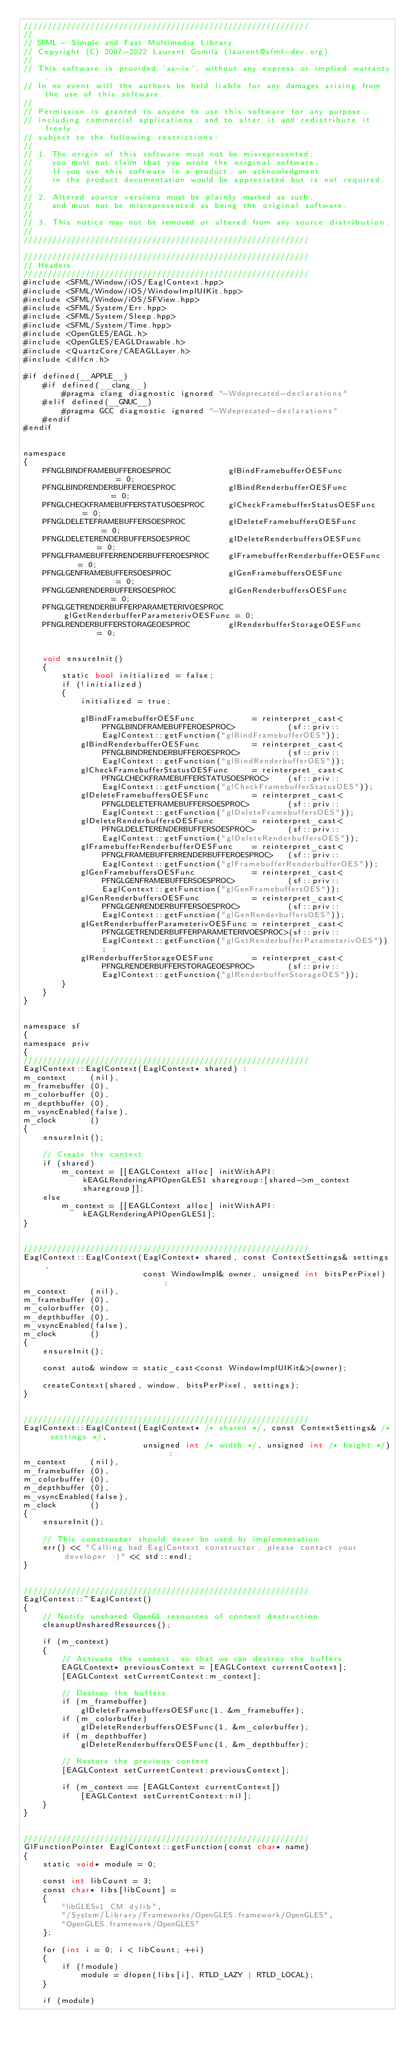<code> <loc_0><loc_0><loc_500><loc_500><_ObjectiveC_>////////////////////////////////////////////////////////////
//
// SFML - Simple and Fast Multimedia Library
// Copyright (C) 2007-2022 Laurent Gomila (laurent@sfml-dev.org)
//
// This software is provided 'as-is', without any express or implied warranty.
// In no event will the authors be held liable for any damages arising from the use of this software.
//
// Permission is granted to anyone to use this software for any purpose,
// including commercial applications, and to alter it and redistribute it freely,
// subject to the following restrictions:
//
// 1. The origin of this software must not be misrepresented;
//    you must not claim that you wrote the original software.
//    If you use this software in a product, an acknowledgment
//    in the product documentation would be appreciated but is not required.
//
// 2. Altered source versions must be plainly marked as such,
//    and must not be misrepresented as being the original software.
//
// 3. This notice may not be removed or altered from any source distribution.
//
////////////////////////////////////////////////////////////

////////////////////////////////////////////////////////////
// Headers
////////////////////////////////////////////////////////////
#include <SFML/Window/iOS/EaglContext.hpp>
#include <SFML/Window/iOS/WindowImplUIKit.hpp>
#include <SFML/Window/iOS/SFView.hpp>
#include <SFML/System/Err.hpp>
#include <SFML/System/Sleep.hpp>
#include <SFML/System/Time.hpp>
#include <OpenGLES/EAGL.h>
#include <OpenGLES/EAGLDrawable.h>
#include <QuartzCore/CAEAGLLayer.h>
#include <dlfcn.h>

#if defined(__APPLE__)
    #if defined(__clang__)
        #pragma clang diagnostic ignored "-Wdeprecated-declarations"
    #elif defined(__GNUC__)
        #pragma GCC diagnostic ignored "-Wdeprecated-declarations"
    #endif
#endif


namespace
{
    PFNGLBINDFRAMEBUFFEROESPROC            glBindFramebufferOESFunc            = 0;
    PFNGLBINDRENDERBUFFEROESPROC           glBindRenderbufferOESFunc           = 0;
    PFNGLCHECKFRAMEBUFFERSTATUSOESPROC     glCheckFramebufferStatusOESFunc     = 0;
    PFNGLDELETEFRAMEBUFFERSOESPROC         glDeleteFramebuffersOESFunc         = 0;
    PFNGLDELETERENDERBUFFERSOESPROC        glDeleteRenderbuffersOESFunc        = 0;
    PFNGLFRAMEBUFFERRENDERBUFFEROESPROC    glFramebufferRenderbufferOESFunc    = 0;
    PFNGLGENFRAMEBUFFERSOESPROC            glGenFramebuffersOESFunc            = 0;
    PFNGLGENRENDERBUFFERSOESPROC           glGenRenderbuffersOESFunc           = 0;
    PFNGLGETRENDERBUFFERPARAMETERIVOESPROC glGetRenderbufferParameterivOESFunc = 0;
    PFNGLRENDERBUFFERSTORAGEOESPROC        glRenderbufferStorageOESFunc        = 0;


    void ensureInit()
    {
        static bool initialized = false;
        if (!initialized)
        {
            initialized = true;

            glBindFramebufferOESFunc            = reinterpret_cast<PFNGLBINDFRAMEBUFFEROESPROC>           (sf::priv::EaglContext::getFunction("glBindFramebufferOES"));
            glBindRenderbufferOESFunc           = reinterpret_cast<PFNGLBINDRENDERBUFFEROESPROC>          (sf::priv::EaglContext::getFunction("glBindRenderbufferOES"));
            glCheckFramebufferStatusOESFunc     = reinterpret_cast<PFNGLCHECKFRAMEBUFFERSTATUSOESPROC>    (sf::priv::EaglContext::getFunction("glCheckFramebufferStatusOES"));
            glDeleteFramebuffersOESFunc         = reinterpret_cast<PFNGLDELETEFRAMEBUFFERSOESPROC>        (sf::priv::EaglContext::getFunction("glDeleteFramebuffersOES"));
            glDeleteRenderbuffersOESFunc        = reinterpret_cast<PFNGLDELETERENDERBUFFERSOESPROC>       (sf::priv::EaglContext::getFunction("glDeleteRenderbuffersOES"));
            glFramebufferRenderbufferOESFunc    = reinterpret_cast<PFNGLFRAMEBUFFERRENDERBUFFEROESPROC>   (sf::priv::EaglContext::getFunction("glFramebufferRenderbufferOES"));
            glGenFramebuffersOESFunc            = reinterpret_cast<PFNGLGENFRAMEBUFFERSOESPROC>           (sf::priv::EaglContext::getFunction("glGenFramebuffersOES"));
            glGenRenderbuffersOESFunc           = reinterpret_cast<PFNGLGENRENDERBUFFERSOESPROC>          (sf::priv::EaglContext::getFunction("glGenRenderbuffersOES"));
            glGetRenderbufferParameterivOESFunc = reinterpret_cast<PFNGLGETRENDERBUFFERPARAMETERIVOESPROC>(sf::priv::EaglContext::getFunction("glGetRenderbufferParameterivOES"));
            glRenderbufferStorageOESFunc        = reinterpret_cast<PFNGLRENDERBUFFERSTORAGEOESPROC>       (sf::priv::EaglContext::getFunction("glRenderbufferStorageOES"));
        }
    }
}


namespace sf
{
namespace priv
{
////////////////////////////////////////////////////////////
EaglContext::EaglContext(EaglContext* shared) :
m_context     (nil),
m_framebuffer (0),
m_colorbuffer (0),
m_depthbuffer (0),
m_vsyncEnabled(false),
m_clock       ()
{
    ensureInit();

    // Create the context
    if (shared)
        m_context = [[EAGLContext alloc] initWithAPI:kEAGLRenderingAPIOpenGLES1 sharegroup:[shared->m_context sharegroup]];
    else
        m_context = [[EAGLContext alloc] initWithAPI:kEAGLRenderingAPIOpenGLES1];
}


////////////////////////////////////////////////////////////
EaglContext::EaglContext(EaglContext* shared, const ContextSettings& settings,
                         const WindowImpl& owner, unsigned int bitsPerPixel) :
m_context     (nil),
m_framebuffer (0),
m_colorbuffer (0),
m_depthbuffer (0),
m_vsyncEnabled(false),
m_clock       ()
{
    ensureInit();

    const auto& window = static_cast<const WindowImplUIKit&>(owner);

    createContext(shared, window, bitsPerPixel, settings);
}


////////////////////////////////////////////////////////////
EaglContext::EaglContext(EaglContext* /* shared */, const ContextSettings& /* settings */,
                         unsigned int /* width */, unsigned int /* height */) :
m_context     (nil),
m_framebuffer (0),
m_colorbuffer (0),
m_depthbuffer (0),
m_vsyncEnabled(false),
m_clock       ()
{
    ensureInit();

    // This constructor should never be used by implementation
    err() << "Calling bad EaglContext constructor, please contact your developer :)" << std::endl;
}


////////////////////////////////////////////////////////////
EaglContext::~EaglContext()
{
    // Notify unshared OpenGL resources of context destruction
    cleanupUnsharedResources();

    if (m_context)
    {
        // Activate the context, so that we can destroy the buffers
        EAGLContext* previousContext = [EAGLContext currentContext];
        [EAGLContext setCurrentContext:m_context];

        // Destroy the buffers
        if (m_framebuffer)
            glDeleteFramebuffersOESFunc(1, &m_framebuffer);
        if (m_colorbuffer)
            glDeleteRenderbuffersOESFunc(1, &m_colorbuffer);
        if (m_depthbuffer)
            glDeleteRenderbuffersOESFunc(1, &m_depthbuffer);

        // Restore the previous context
        [EAGLContext setCurrentContext:previousContext];

        if (m_context == [EAGLContext currentContext])
            [EAGLContext setCurrentContext:nil];
    }
}


////////////////////////////////////////////////////////////
GlFunctionPointer EaglContext::getFunction(const char* name)
{
    static void* module = 0;

    const int libCount = 3;
    const char* libs[libCount] =
    {
        "libGLESv1_CM.dylib",
        "/System/Library/Frameworks/OpenGLES.framework/OpenGLES",
        "OpenGLES.framework/OpenGLES"
    };

    for (int i = 0; i < libCount; ++i)
    {
        if (!module)
            module = dlopen(libs[i], RTLD_LAZY | RTLD_LOCAL);
    }

    if (module)</code> 